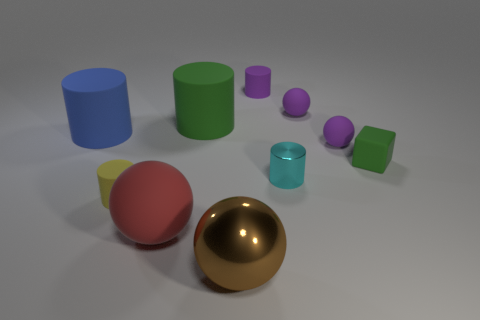What time of day or lighting conditions does the setting suggest? The setting is indeterminate regarding the time of day, as it's likely a controlled lighting environment possibly resembling studio lighting with soft shadows, implying an indoor photo shoot or a 3D render with artificial light sources. 